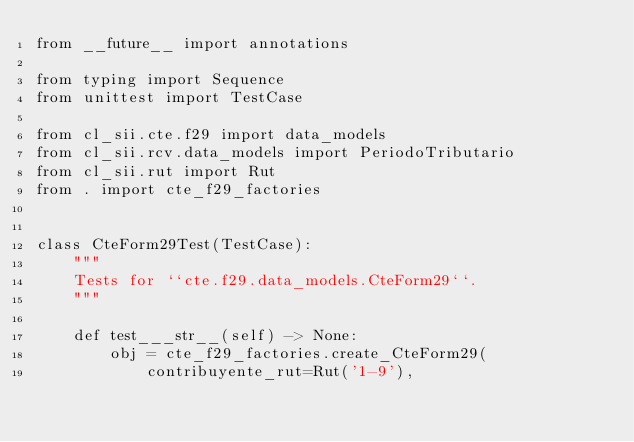Convert code to text. <code><loc_0><loc_0><loc_500><loc_500><_Python_>from __future__ import annotations

from typing import Sequence
from unittest import TestCase

from cl_sii.cte.f29 import data_models
from cl_sii.rcv.data_models import PeriodoTributario
from cl_sii.rut import Rut
from . import cte_f29_factories


class CteForm29Test(TestCase):
    """
    Tests for ``cte.f29.data_models.CteForm29``.
    """

    def test___str__(self) -> None:
        obj = cte_f29_factories.create_CteForm29(
            contribuyente_rut=Rut('1-9'),</code> 